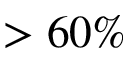<formula> <loc_0><loc_0><loc_500><loc_500>> 6 0 \%</formula> 